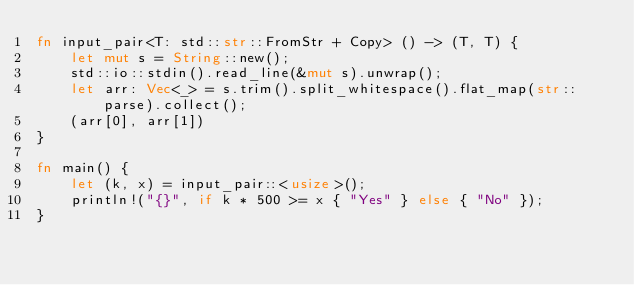Convert code to text. <code><loc_0><loc_0><loc_500><loc_500><_Rust_>fn input_pair<T: std::str::FromStr + Copy> () -> (T, T) {
    let mut s = String::new();
    std::io::stdin().read_line(&mut s).unwrap();
    let arr: Vec<_> = s.trim().split_whitespace().flat_map(str::parse).collect();
    (arr[0], arr[1])
}

fn main() {
    let (k, x) = input_pair::<usize>();
    println!("{}", if k * 500 >= x { "Yes" } else { "No" });
}
</code> 